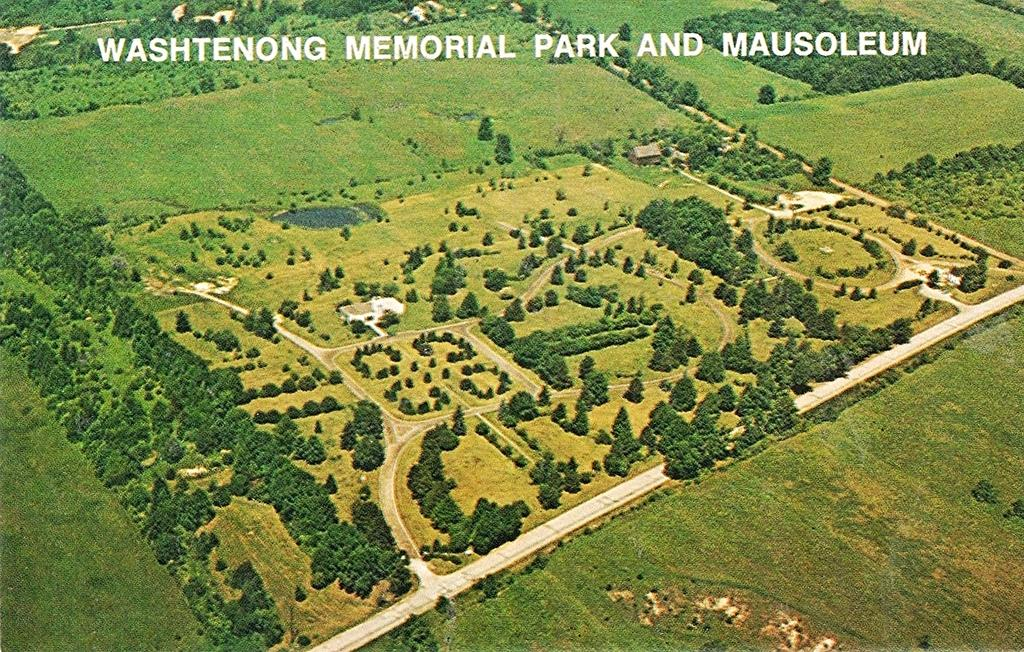What type of scenery can be seen from left to right in the image? There is greenery visible from left to right in the image. What is located at the top of the image? There is text on the top of the image. What type of fan can be seen in the image? There is no fan present in the image. What type of metal is used to create the text in the image? There is no metal present in the image, as the text appears to be digital or printed. 